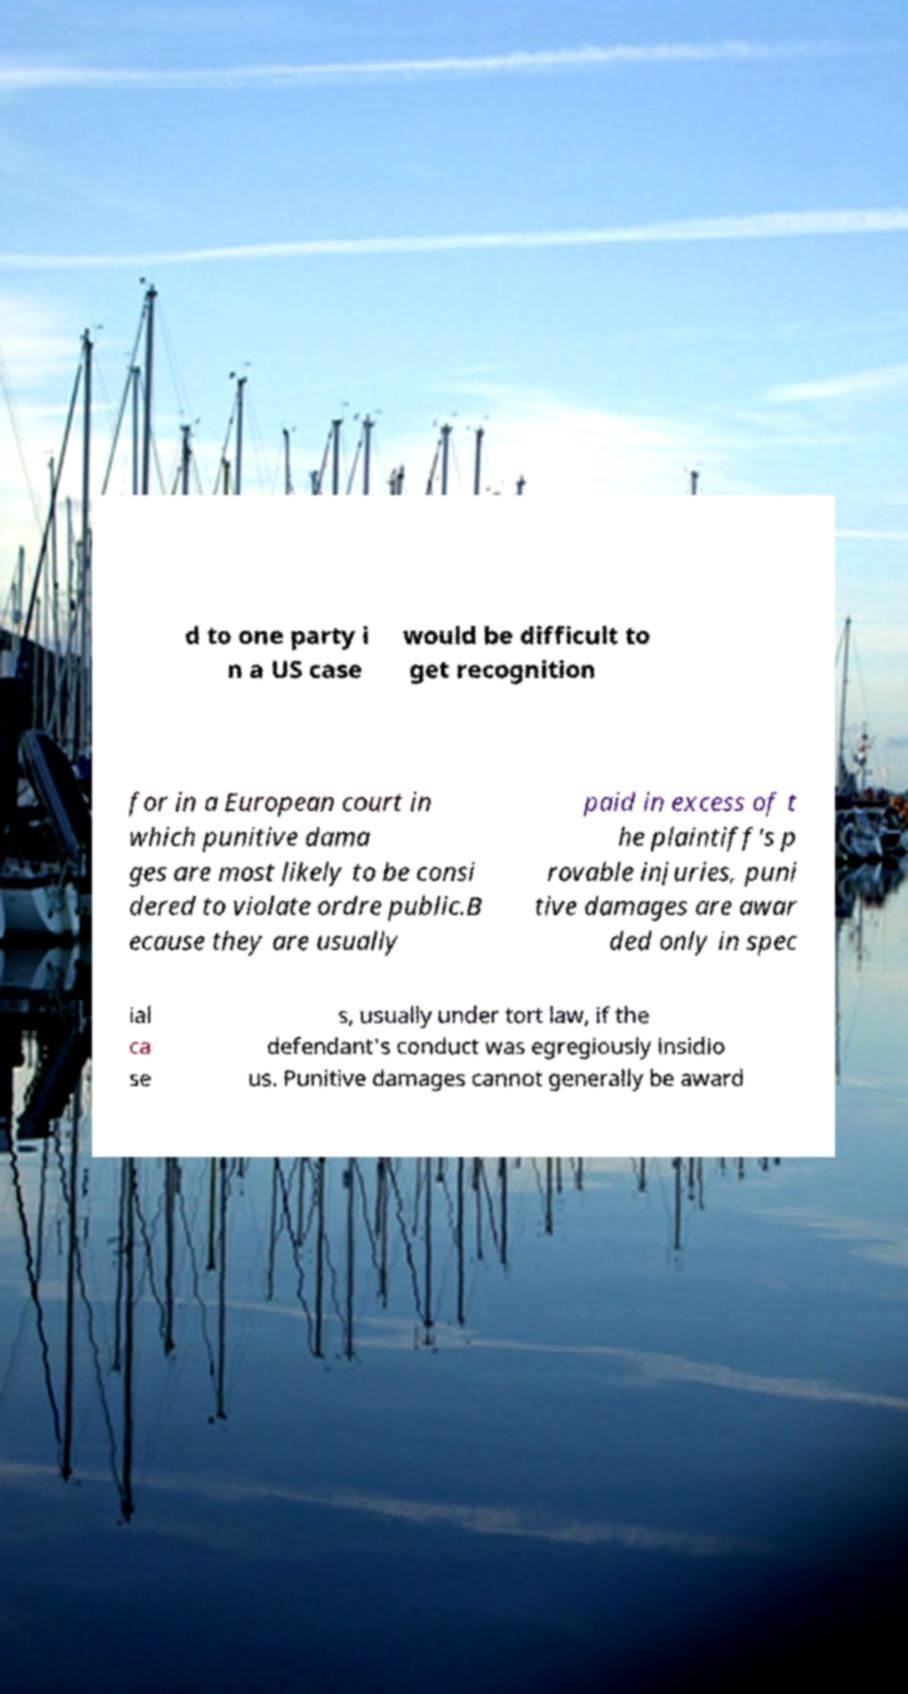Can you accurately transcribe the text from the provided image for me? d to one party i n a US case would be difficult to get recognition for in a European court in which punitive dama ges are most likely to be consi dered to violate ordre public.B ecause they are usually paid in excess of t he plaintiff's p rovable injuries, puni tive damages are awar ded only in spec ial ca se s, usually under tort law, if the defendant's conduct was egregiously insidio us. Punitive damages cannot generally be award 